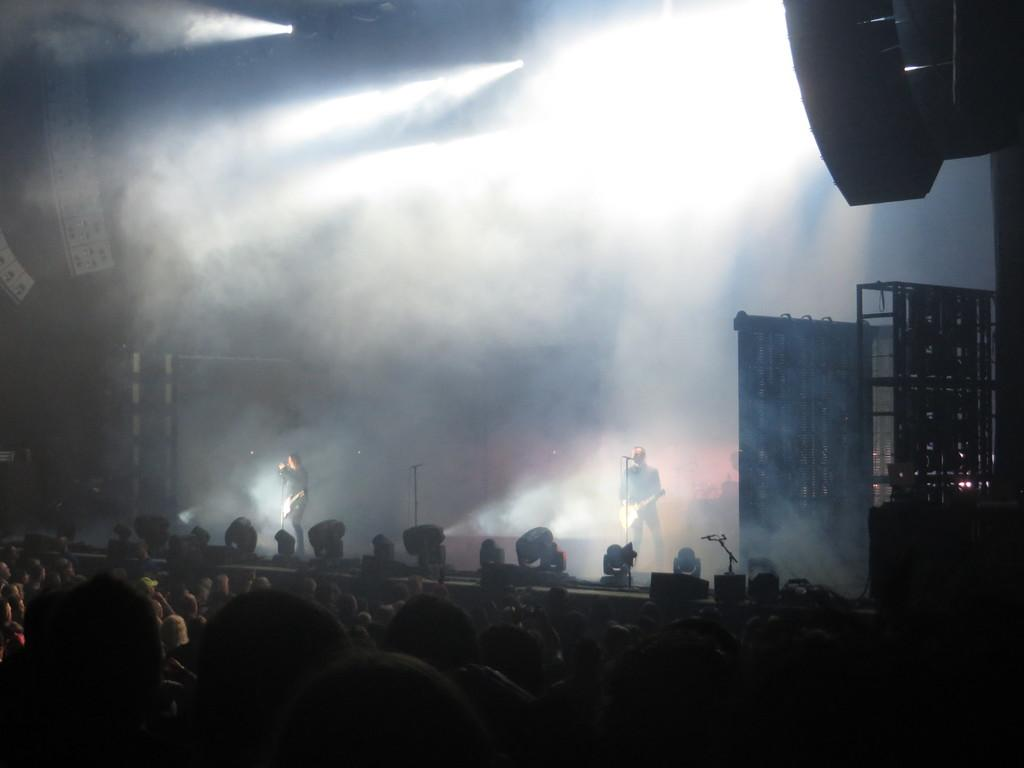What is the main object in the picture? There is a dais in the picture. What is happening on the dais? There are two persons standing on the dais. What can be seen in the picture besides the dais and the people? There are lights visible in the picture. Who is present in the picture besides the two persons on the dais? There is an audience present in the picture. What type of hose is being used by the person on the dais? There is no hose present in the image; it features a dais with two persons standing on it and an audience. How does the twist in the performance affect the audience's reaction? There is no mention of a twist in the performance, and the audience's reaction cannot be determined from the image alone. 